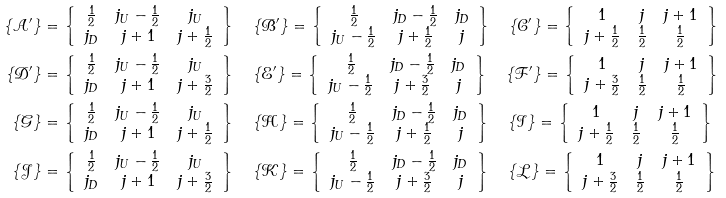Convert formula to latex. <formula><loc_0><loc_0><loc_500><loc_500>\{ \mathcal { A ^ { \prime } } \} & = \left \{ \begin{array} { c c c } \frac { 1 } { 2 } & j _ { U } - \frac { 1 } { 2 } & j _ { U } \\ j _ { D } & j + 1 & j + \frac { 1 } { 2 } \end{array} \right \} \quad \{ \mathcal { B ^ { \prime } } \} = \left \{ \begin{array} { c c c } \frac { 1 } { 2 } & j _ { D } - \frac { 1 } { 2 } & j _ { D } \\ j _ { U } - \frac { 1 } { 2 } & j + \frac { 1 } { 2 } & j \end{array} \right \} \quad \{ \mathcal { C ^ { \prime } } \} = \left \{ \begin{array} { c c c } 1 & j & j + 1 \\ j + \frac { 1 } { 2 } & \frac { 1 } { 2 } & \frac { 1 } { 2 } \end{array} \right \} \\ \{ \mathcal { D ^ { \prime } } \} & = \left \{ \begin{array} { c c c } \frac { 1 } { 2 } & j _ { U } - \frac { 1 } { 2 } & j _ { U } \\ j _ { D } & j + 1 & j + \frac { 3 } { 2 } \end{array} \right \} \quad \{ \mathcal { E ^ { \prime } } \} = \left \{ \begin{array} { c c c } \frac { 1 } { 2 } & j _ { D } - \frac { 1 } { 2 } & j _ { D } \\ j _ { U } - \frac { 1 } { 2 } & j + \frac { 3 } { 2 } & j \end{array} \right \} \quad \{ \mathcal { F ^ { \prime } } \} = \left \{ \begin{array} { c c c } 1 & j & j + 1 \\ j + \frac { 3 } { 2 } & \frac { 1 } { 2 } & \frac { 1 } { 2 } \end{array} \right \} \\ \{ \mathcal { G } \} & = \left \{ \begin{array} { c c c } \frac { 1 } { 2 } & j _ { U } - \frac { 1 } { 2 } & j _ { U } \\ j _ { D } & j + 1 & j + \frac { 1 } { 2 } \end{array} \right \} \quad \{ \mathcal { H } \} = \left \{ \begin{array} { c c c } \frac { 1 } { 2 } & j _ { D } - \frac { 1 } { 2 } & j _ { D } \\ j _ { U } - \frac { 1 } { 2 } & j + \frac { 1 } { 2 } & j \end{array} \right \} \quad \{ \mathcal { I } \} = \left \{ \begin{array} { c c c } 1 & j & j + 1 \\ j + \frac { 1 } { 2 } & \frac { 1 } { 2 } & \frac { 1 } { 2 } \end{array} \right \} \\ \{ \mathcal { J } \} & = \left \{ \begin{array} { c c c } \frac { 1 } { 2 } & j _ { U } - \frac { 1 } { 2 } & j _ { U } \\ j _ { D } & j + 1 & j + \frac { 3 } { 2 } \end{array} \right \} \quad \{ \mathcal { K } \} = \left \{ \begin{array} { c c c } \frac { 1 } { 2 } & j _ { D } - \frac { 1 } { 2 } & j _ { D } \\ j _ { U } - \frac { 1 } { 2 } & j + \frac { 3 } { 2 } & j \end{array} \right \} \quad \{ \mathcal { L } \} = \left \{ \begin{array} { c c c } 1 & j & j + 1 \\ j + \frac { 3 } { 2 } & \frac { 1 } { 2 } & \frac { 1 } { 2 } \end{array} \right \} \\</formula> 